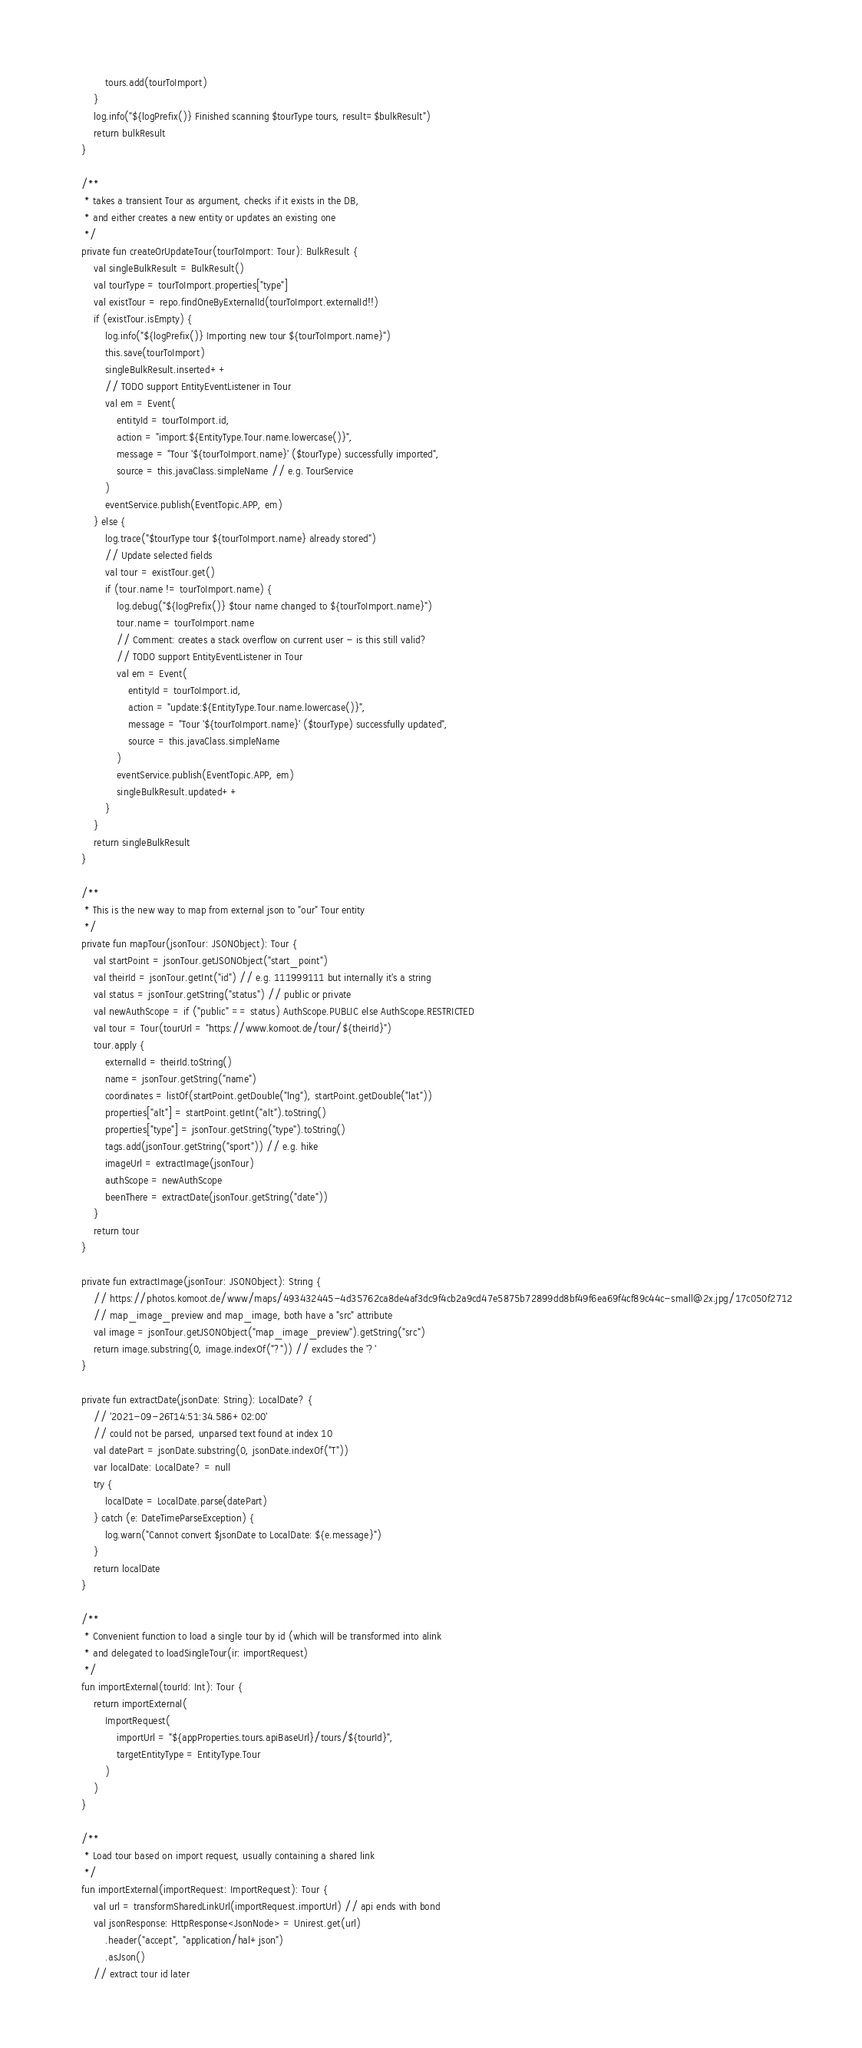<code> <loc_0><loc_0><loc_500><loc_500><_Kotlin_>            tours.add(tourToImport)
        }
        log.info("${logPrefix()} Finished scanning $tourType tours, result=$bulkResult")
        return bulkResult
    }

    /**
     * takes a transient Tour as argument, checks if it exists in the DB,
     * and either creates a new entity or updates an existing one
     */
    private fun createOrUpdateTour(tourToImport: Tour): BulkResult {
        val singleBulkResult = BulkResult()
        val tourType = tourToImport.properties["type"]
        val existTour = repo.findOneByExternalId(tourToImport.externalId!!)
        if (existTour.isEmpty) {
            log.info("${logPrefix()} Importing new tour ${tourToImport.name}")
            this.save(tourToImport)
            singleBulkResult.inserted++
            // TODO support EntityEventListener in Tour
            val em = Event(
                entityId = tourToImport.id,
                action = "import:${EntityType.Tour.name.lowercase()}",
                message = "Tour '${tourToImport.name}' ($tourType) successfully imported",
                source = this.javaClass.simpleName // e.g. TourService
            )
            eventService.publish(EventTopic.APP, em)
        } else {
            log.trace("$tourType tour ${tourToImport.name} already stored")
            // Update selected fields
            val tour = existTour.get()
            if (tour.name != tourToImport.name) {
                log.debug("${logPrefix()} $tour name changed to ${tourToImport.name}")
                tour.name = tourToImport.name
                // Comment: creates a stack overflow on current user - is this still valid?
                // TODO support EntityEventListener in Tour
                val em = Event(
                    entityId = tourToImport.id,
                    action = "update:${EntityType.Tour.name.lowercase()}",
                    message = "Tour '${tourToImport.name}' ($tourType) successfully updated",
                    source = this.javaClass.simpleName
                )
                eventService.publish(EventTopic.APP, em)
                singleBulkResult.updated++
            }
        }
        return singleBulkResult
    }

    /**
     * This is the new way to map from external json to "our" Tour entity
     */
    private fun mapTour(jsonTour: JSONObject): Tour {
        val startPoint = jsonTour.getJSONObject("start_point")
        val theirId = jsonTour.getInt("id") // e.g. 111999111 but internally it's a string
        val status = jsonTour.getString("status") // public or private
        val newAuthScope = if ("public" == status) AuthScope.PUBLIC else AuthScope.RESTRICTED
        val tour = Tour(tourUrl = "https://www.komoot.de/tour/${theirId}")
        tour.apply {
            externalId = theirId.toString()
            name = jsonTour.getString("name")
            coordinates = listOf(startPoint.getDouble("lng"), startPoint.getDouble("lat"))
            properties["alt"] = startPoint.getInt("alt").toString()
            properties["type"] = jsonTour.getString("type").toString()
            tags.add(jsonTour.getString("sport")) // e.g. hike
            imageUrl = extractImage(jsonTour)
            authScope = newAuthScope
            beenThere = extractDate(jsonTour.getString("date"))
        }
        return tour
    }

    private fun extractImage(jsonTour: JSONObject): String {
        // https://photos.komoot.de/www/maps/493432445-4d35762ca8de4af3dc9f4cb2a9cd47e5875b72899dd8bf49f6ea69f4cf89c44c-small@2x.jpg/17c050f2712
        // map_image_preview and map_image, both have a "src" attribute
        val image = jsonTour.getJSONObject("map_image_preview").getString("src")
        return image.substring(0, image.indexOf("?")) // excludes the '?'
    }

    private fun extractDate(jsonDate: String): LocalDate? {
        // '2021-09-26T14:51:34.586+02:00'
        // could not be parsed, unparsed text found at index 10
        val datePart = jsonDate.substring(0, jsonDate.indexOf("T"))
        var localDate: LocalDate? = null
        try {
            localDate = LocalDate.parse(datePart)
        } catch (e: DateTimeParseException) {
            log.warn("Cannot convert $jsonDate to LocalDate: ${e.message}")
        }
        return localDate
    }

    /**
     * Convenient function to load a single tour by id (which will be transformed into alink
     * and delegated to loadSingleTour(ir: importRequest)
     */
    fun importExternal(tourId: Int): Tour {
        return importExternal(
            ImportRequest(
                importUrl = "${appProperties.tours.apiBaseUrl}/tours/${tourId}",
                targetEntityType = EntityType.Tour
            )
        )
    }

    /**
     * Load tour based on import request, usually containing a shared link
     */
    fun importExternal(importRequest: ImportRequest): Tour {
        val url = transformSharedLinkUrl(importRequest.importUrl) // api ends with bond
        val jsonResponse: HttpResponse<JsonNode> = Unirest.get(url)
            .header("accept", "application/hal+json")
            .asJson()
        // extract tour id later</code> 